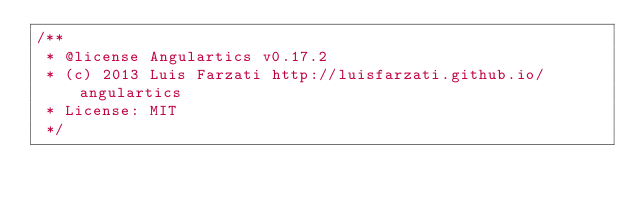<code> <loc_0><loc_0><loc_500><loc_500><_JavaScript_>/**
 * @license Angulartics v0.17.2
 * (c) 2013 Luis Farzati http://luisfarzati.github.io/angulartics
 * License: MIT
 */</code> 